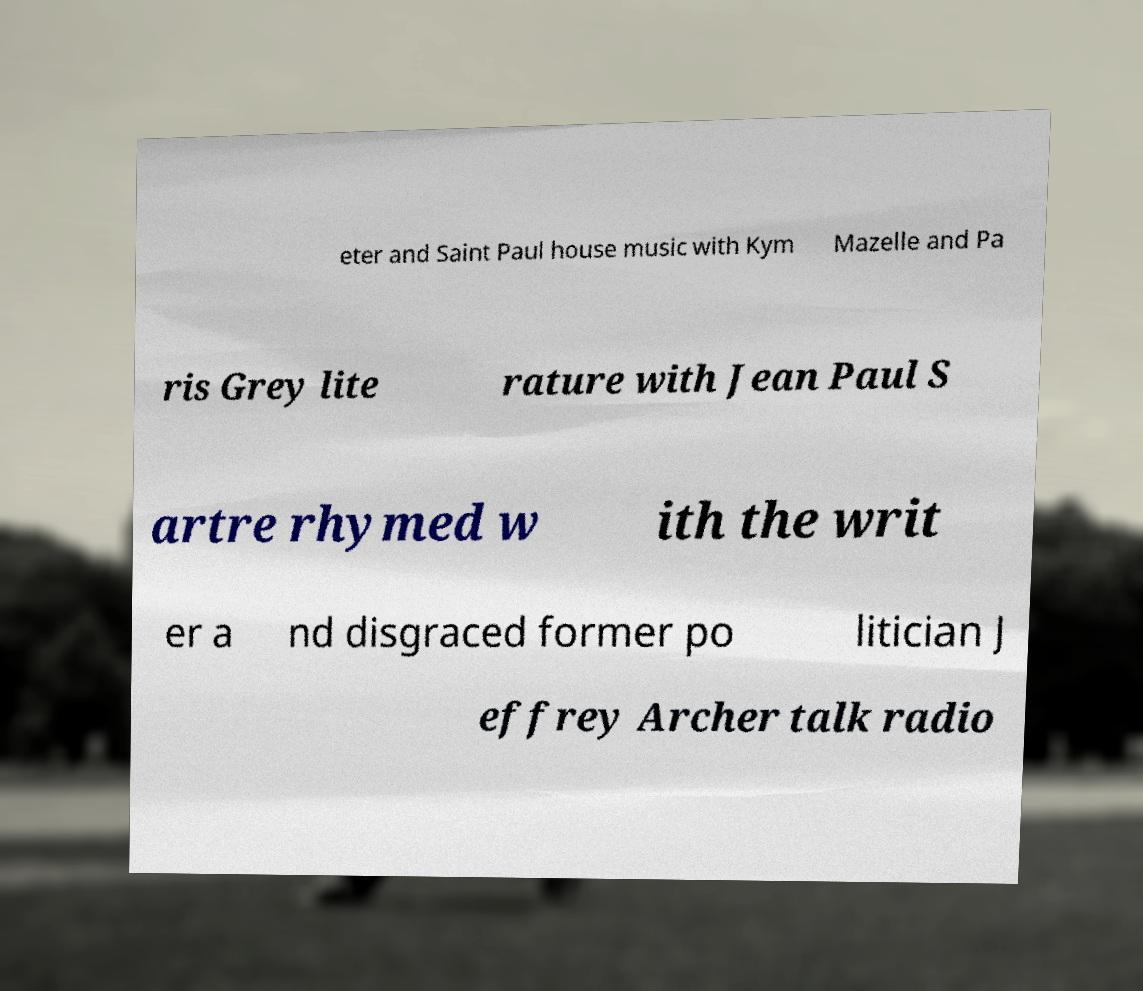Please read and relay the text visible in this image. What does it say? eter and Saint Paul house music with Kym Mazelle and Pa ris Grey lite rature with Jean Paul S artre rhymed w ith the writ er a nd disgraced former po litician J effrey Archer talk radio 